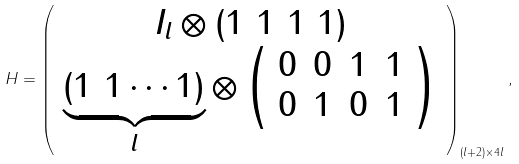<formula> <loc_0><loc_0><loc_500><loc_500>H = \left ( \begin{array} { c } I _ { l } \otimes ( 1 \ 1 \ 1 \ 1 ) \\ \underbrace { ( 1 \ 1 \cdots 1 ) } _ { l } \otimes \left ( \begin{array} { c c c c } 0 & 0 & 1 & 1 \\ 0 & 1 & 0 & 1 \\ \end{array} \right ) \\ \end{array} \right ) _ { ( l + 2 ) \times 4 l } ,</formula> 